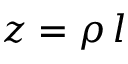<formula> <loc_0><loc_0><loc_500><loc_500>z = \rho \, l</formula> 